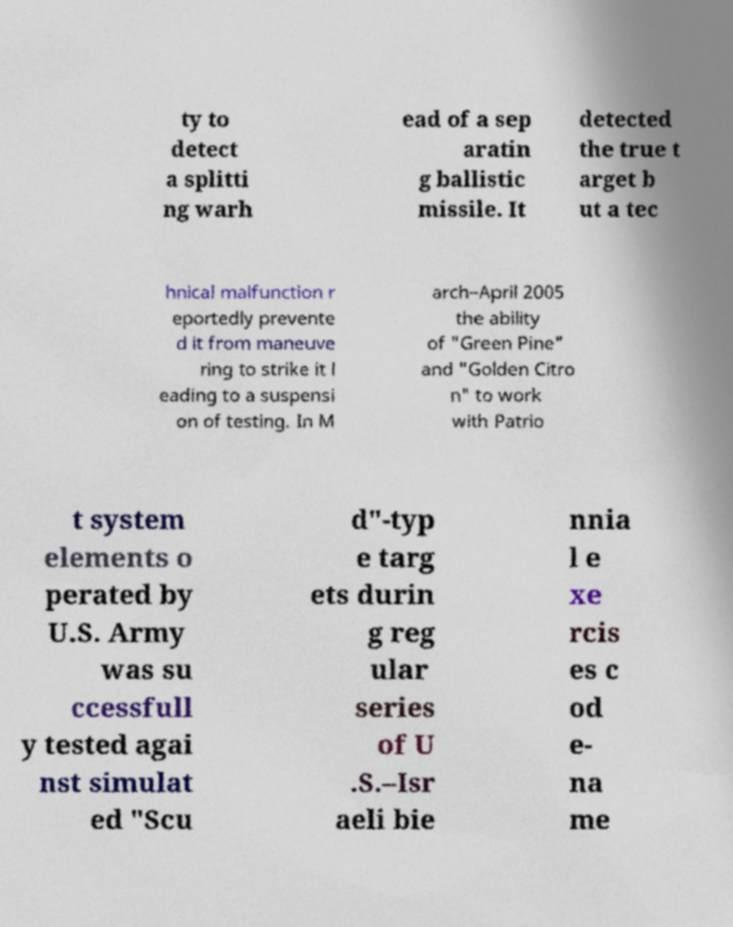Could you extract and type out the text from this image? ty to detect a splitti ng warh ead of a sep aratin g ballistic missile. It detected the true t arget b ut a tec hnical malfunction r eportedly prevente d it from maneuve ring to strike it l eading to a suspensi on of testing. In M arch–April 2005 the ability of "Green Pine" and "Golden Citro n" to work with Patrio t system elements o perated by U.S. Army was su ccessfull y tested agai nst simulat ed "Scu d"-typ e targ ets durin g reg ular series of U .S.–Isr aeli bie nnia l e xe rcis es c od e- na me 